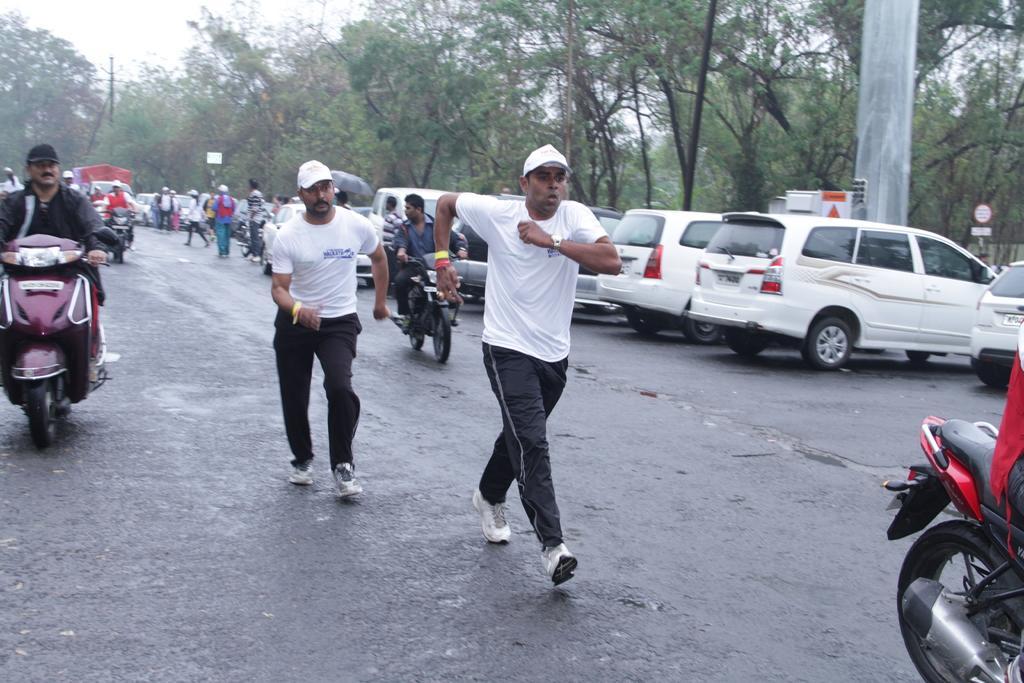Could you give a brief overview of what you see in this image? There are two people running and few people riding the motorbikes on the road. These are the cars, which are parked. I can see few people standing. This looks like a pole. These are the trees. On the right side of the image, I can see a board, which is attached to a pole. 